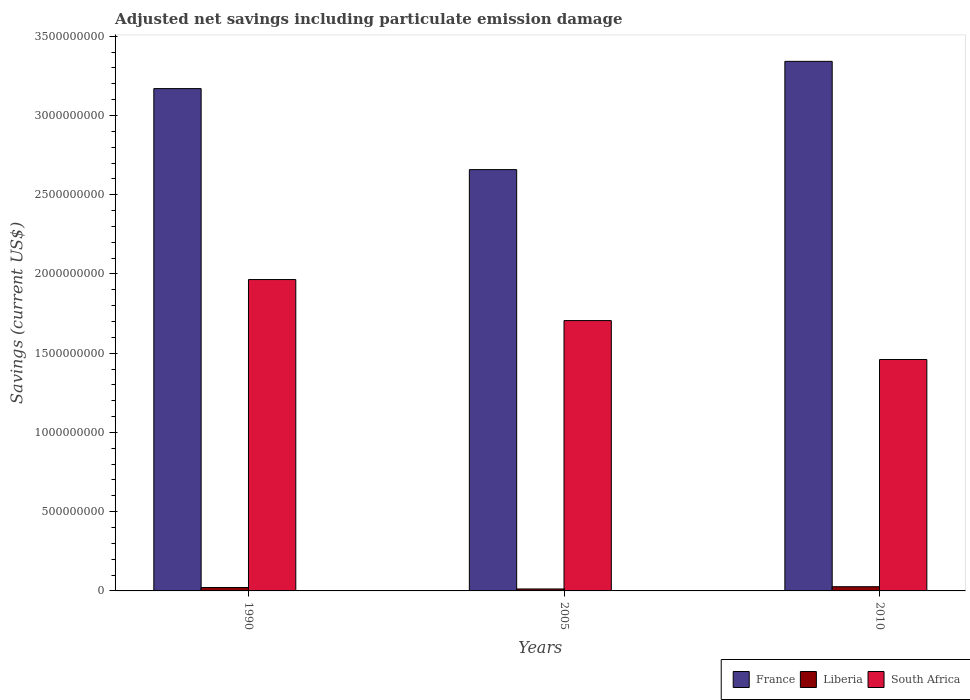How many different coloured bars are there?
Make the answer very short. 3. How many groups of bars are there?
Your answer should be very brief. 3. How many bars are there on the 2nd tick from the left?
Your answer should be very brief. 3. How many bars are there on the 3rd tick from the right?
Offer a very short reply. 3. In how many cases, is the number of bars for a given year not equal to the number of legend labels?
Keep it short and to the point. 0. What is the net savings in South Africa in 1990?
Ensure brevity in your answer.  1.96e+09. Across all years, what is the maximum net savings in South Africa?
Offer a terse response. 1.96e+09. Across all years, what is the minimum net savings in France?
Your answer should be compact. 2.66e+09. What is the total net savings in South Africa in the graph?
Your response must be concise. 5.13e+09. What is the difference between the net savings in South Africa in 1990 and that in 2010?
Offer a very short reply. 5.05e+08. What is the difference between the net savings in South Africa in 2005 and the net savings in Liberia in 1990?
Offer a terse response. 1.68e+09. What is the average net savings in Liberia per year?
Provide a succinct answer. 2.02e+07. In the year 1990, what is the difference between the net savings in South Africa and net savings in Liberia?
Give a very brief answer. 1.94e+09. In how many years, is the net savings in South Africa greater than 3200000000 US$?
Provide a short and direct response. 0. What is the ratio of the net savings in South Africa in 1990 to that in 2005?
Keep it short and to the point. 1.15. What is the difference between the highest and the second highest net savings in South Africa?
Make the answer very short. 2.59e+08. What is the difference between the highest and the lowest net savings in Liberia?
Give a very brief answer. 1.43e+07. In how many years, is the net savings in Liberia greater than the average net savings in Liberia taken over all years?
Give a very brief answer. 2. What does the 2nd bar from the left in 2005 represents?
Keep it short and to the point. Liberia. What does the 3rd bar from the right in 2010 represents?
Your answer should be compact. France. Are all the bars in the graph horizontal?
Your answer should be compact. No. How many years are there in the graph?
Your response must be concise. 3. Where does the legend appear in the graph?
Offer a very short reply. Bottom right. What is the title of the graph?
Offer a very short reply. Adjusted net savings including particulate emission damage. Does "Japan" appear as one of the legend labels in the graph?
Make the answer very short. No. What is the label or title of the X-axis?
Make the answer very short. Years. What is the label or title of the Y-axis?
Provide a succinct answer. Savings (current US$). What is the Savings (current US$) of France in 1990?
Keep it short and to the point. 3.17e+09. What is the Savings (current US$) of Liberia in 1990?
Ensure brevity in your answer.  2.16e+07. What is the Savings (current US$) in South Africa in 1990?
Make the answer very short. 1.96e+09. What is the Savings (current US$) in France in 2005?
Make the answer very short. 2.66e+09. What is the Savings (current US$) in Liberia in 2005?
Your answer should be very brief. 1.23e+07. What is the Savings (current US$) of South Africa in 2005?
Offer a very short reply. 1.71e+09. What is the Savings (current US$) of France in 2010?
Offer a terse response. 3.34e+09. What is the Savings (current US$) in Liberia in 2010?
Keep it short and to the point. 2.66e+07. What is the Savings (current US$) of South Africa in 2010?
Provide a short and direct response. 1.46e+09. Across all years, what is the maximum Savings (current US$) in France?
Offer a terse response. 3.34e+09. Across all years, what is the maximum Savings (current US$) in Liberia?
Your answer should be very brief. 2.66e+07. Across all years, what is the maximum Savings (current US$) in South Africa?
Your answer should be compact. 1.96e+09. Across all years, what is the minimum Savings (current US$) in France?
Keep it short and to the point. 2.66e+09. Across all years, what is the minimum Savings (current US$) in Liberia?
Your answer should be very brief. 1.23e+07. Across all years, what is the minimum Savings (current US$) of South Africa?
Give a very brief answer. 1.46e+09. What is the total Savings (current US$) of France in the graph?
Provide a short and direct response. 9.17e+09. What is the total Savings (current US$) of Liberia in the graph?
Offer a very short reply. 6.05e+07. What is the total Savings (current US$) in South Africa in the graph?
Provide a succinct answer. 5.13e+09. What is the difference between the Savings (current US$) in France in 1990 and that in 2005?
Your answer should be very brief. 5.11e+08. What is the difference between the Savings (current US$) of Liberia in 1990 and that in 2005?
Your response must be concise. 9.22e+06. What is the difference between the Savings (current US$) in South Africa in 1990 and that in 2005?
Ensure brevity in your answer.  2.59e+08. What is the difference between the Savings (current US$) in France in 1990 and that in 2010?
Offer a very short reply. -1.72e+08. What is the difference between the Savings (current US$) of Liberia in 1990 and that in 2010?
Offer a terse response. -5.05e+06. What is the difference between the Savings (current US$) in South Africa in 1990 and that in 2010?
Your response must be concise. 5.05e+08. What is the difference between the Savings (current US$) in France in 2005 and that in 2010?
Provide a short and direct response. -6.83e+08. What is the difference between the Savings (current US$) of Liberia in 2005 and that in 2010?
Offer a terse response. -1.43e+07. What is the difference between the Savings (current US$) of South Africa in 2005 and that in 2010?
Provide a short and direct response. 2.46e+08. What is the difference between the Savings (current US$) of France in 1990 and the Savings (current US$) of Liberia in 2005?
Offer a very short reply. 3.16e+09. What is the difference between the Savings (current US$) in France in 1990 and the Savings (current US$) in South Africa in 2005?
Give a very brief answer. 1.46e+09. What is the difference between the Savings (current US$) of Liberia in 1990 and the Savings (current US$) of South Africa in 2005?
Your answer should be compact. -1.68e+09. What is the difference between the Savings (current US$) of France in 1990 and the Savings (current US$) of Liberia in 2010?
Give a very brief answer. 3.14e+09. What is the difference between the Savings (current US$) of France in 1990 and the Savings (current US$) of South Africa in 2010?
Your answer should be very brief. 1.71e+09. What is the difference between the Savings (current US$) of Liberia in 1990 and the Savings (current US$) of South Africa in 2010?
Make the answer very short. -1.44e+09. What is the difference between the Savings (current US$) of France in 2005 and the Savings (current US$) of Liberia in 2010?
Your response must be concise. 2.63e+09. What is the difference between the Savings (current US$) of France in 2005 and the Savings (current US$) of South Africa in 2010?
Provide a short and direct response. 1.20e+09. What is the difference between the Savings (current US$) in Liberia in 2005 and the Savings (current US$) in South Africa in 2010?
Your answer should be compact. -1.45e+09. What is the average Savings (current US$) of France per year?
Offer a very short reply. 3.06e+09. What is the average Savings (current US$) in Liberia per year?
Provide a succinct answer. 2.02e+07. What is the average Savings (current US$) in South Africa per year?
Ensure brevity in your answer.  1.71e+09. In the year 1990, what is the difference between the Savings (current US$) of France and Savings (current US$) of Liberia?
Your answer should be very brief. 3.15e+09. In the year 1990, what is the difference between the Savings (current US$) of France and Savings (current US$) of South Africa?
Make the answer very short. 1.20e+09. In the year 1990, what is the difference between the Savings (current US$) of Liberia and Savings (current US$) of South Africa?
Provide a short and direct response. -1.94e+09. In the year 2005, what is the difference between the Savings (current US$) of France and Savings (current US$) of Liberia?
Ensure brevity in your answer.  2.65e+09. In the year 2005, what is the difference between the Savings (current US$) in France and Savings (current US$) in South Africa?
Ensure brevity in your answer.  9.53e+08. In the year 2005, what is the difference between the Savings (current US$) of Liberia and Savings (current US$) of South Africa?
Keep it short and to the point. -1.69e+09. In the year 2010, what is the difference between the Savings (current US$) in France and Savings (current US$) in Liberia?
Your answer should be very brief. 3.32e+09. In the year 2010, what is the difference between the Savings (current US$) of France and Savings (current US$) of South Africa?
Provide a succinct answer. 1.88e+09. In the year 2010, what is the difference between the Savings (current US$) in Liberia and Savings (current US$) in South Africa?
Offer a very short reply. -1.43e+09. What is the ratio of the Savings (current US$) of France in 1990 to that in 2005?
Provide a short and direct response. 1.19. What is the ratio of the Savings (current US$) in Liberia in 1990 to that in 2005?
Make the answer very short. 1.75. What is the ratio of the Savings (current US$) in South Africa in 1990 to that in 2005?
Offer a very short reply. 1.15. What is the ratio of the Savings (current US$) in France in 1990 to that in 2010?
Your answer should be compact. 0.95. What is the ratio of the Savings (current US$) in Liberia in 1990 to that in 2010?
Ensure brevity in your answer.  0.81. What is the ratio of the Savings (current US$) of South Africa in 1990 to that in 2010?
Your answer should be compact. 1.35. What is the ratio of the Savings (current US$) in France in 2005 to that in 2010?
Provide a short and direct response. 0.8. What is the ratio of the Savings (current US$) in Liberia in 2005 to that in 2010?
Your answer should be compact. 0.46. What is the ratio of the Savings (current US$) of South Africa in 2005 to that in 2010?
Offer a terse response. 1.17. What is the difference between the highest and the second highest Savings (current US$) of France?
Make the answer very short. 1.72e+08. What is the difference between the highest and the second highest Savings (current US$) in Liberia?
Give a very brief answer. 5.05e+06. What is the difference between the highest and the second highest Savings (current US$) of South Africa?
Your answer should be very brief. 2.59e+08. What is the difference between the highest and the lowest Savings (current US$) in France?
Make the answer very short. 6.83e+08. What is the difference between the highest and the lowest Savings (current US$) of Liberia?
Your answer should be compact. 1.43e+07. What is the difference between the highest and the lowest Savings (current US$) of South Africa?
Provide a succinct answer. 5.05e+08. 